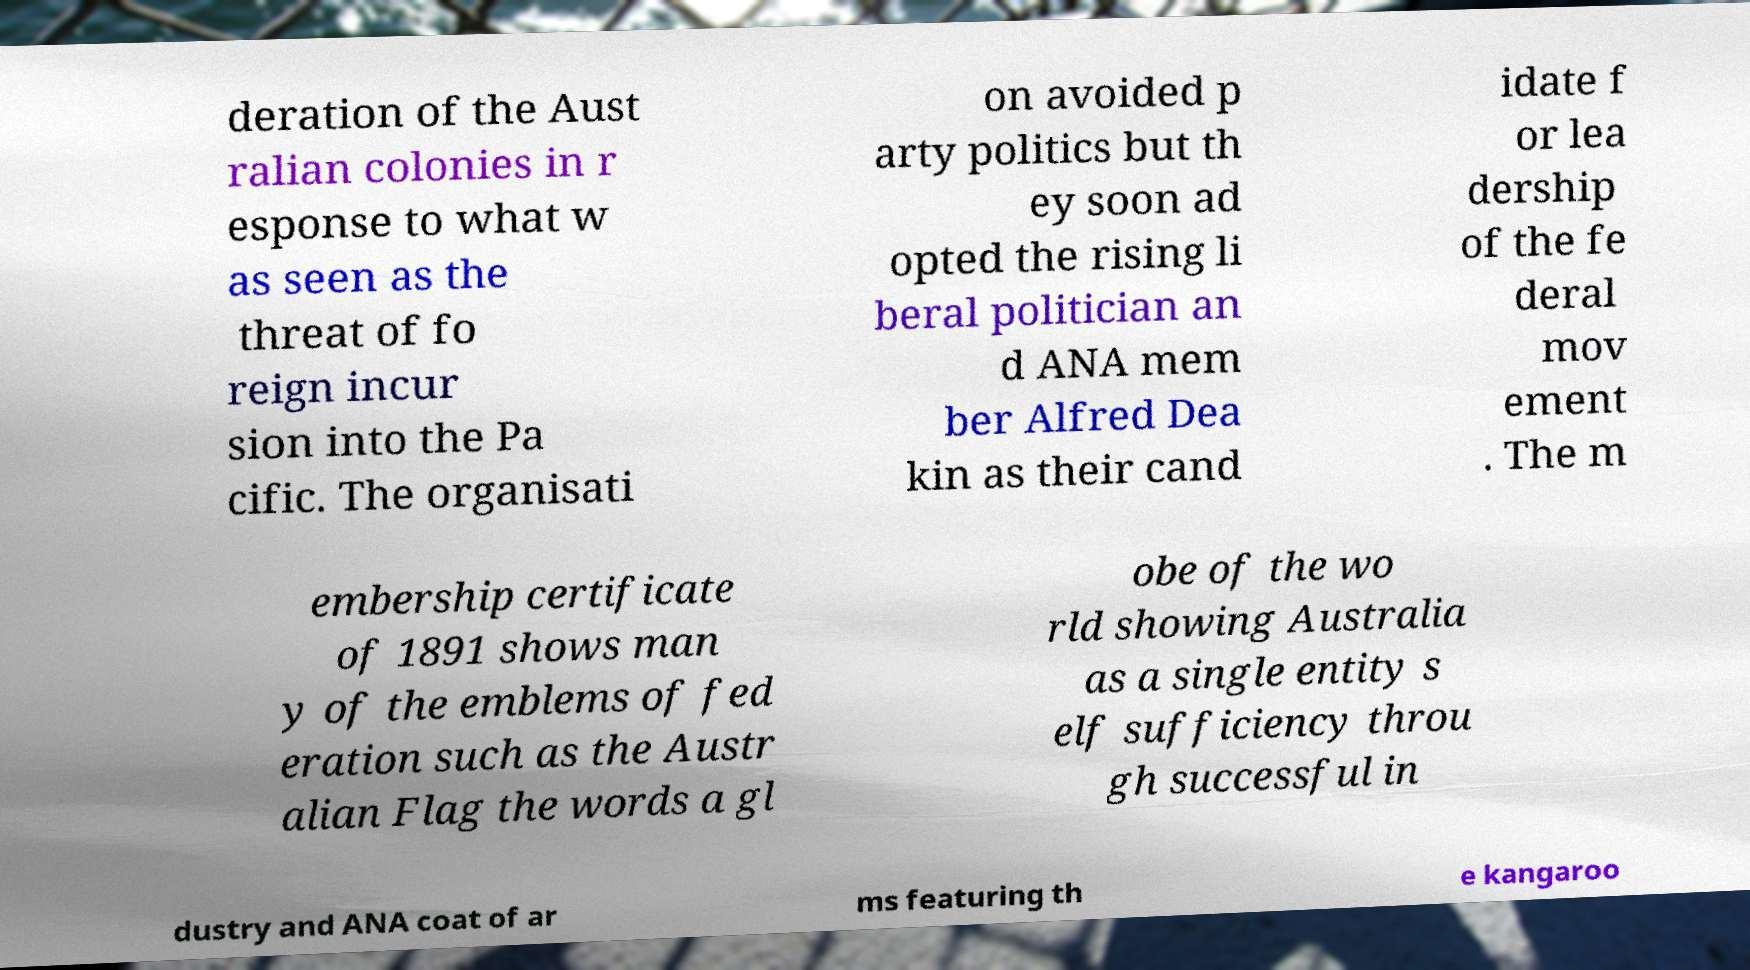There's text embedded in this image that I need extracted. Can you transcribe it verbatim? deration of the Aust ralian colonies in r esponse to what w as seen as the threat of fo reign incur sion into the Pa cific. The organisati on avoided p arty politics but th ey soon ad opted the rising li beral politician an d ANA mem ber Alfred Dea kin as their cand idate f or lea dership of the fe deral mov ement . The m embership certificate of 1891 shows man y of the emblems of fed eration such as the Austr alian Flag the words a gl obe of the wo rld showing Australia as a single entity s elf sufficiency throu gh successful in dustry and ANA coat of ar ms featuring th e kangaroo 